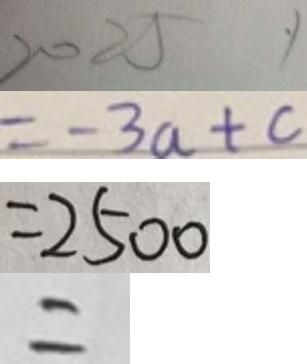<formula> <loc_0><loc_0><loc_500><loc_500>2 0 2 5 y 
 = - 3 a + c 
 = 2 5 0 0 
 =</formula> 